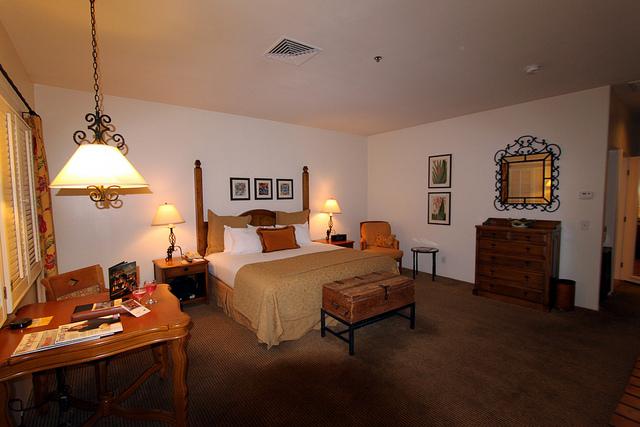What color are the walls?
Keep it brief. White. Are there any people in this photo?
Be succinct. No. What room is this?
Give a very brief answer. Bedroom. What material is the floor in this scene made of?
Keep it brief. Wood. What shape is the artwork on the wall behind the bed?
Short answer required. Square. What is the shape of the mirror?
Keep it brief. Square. What is in front of the mirror?
Write a very short answer. Dresser. 